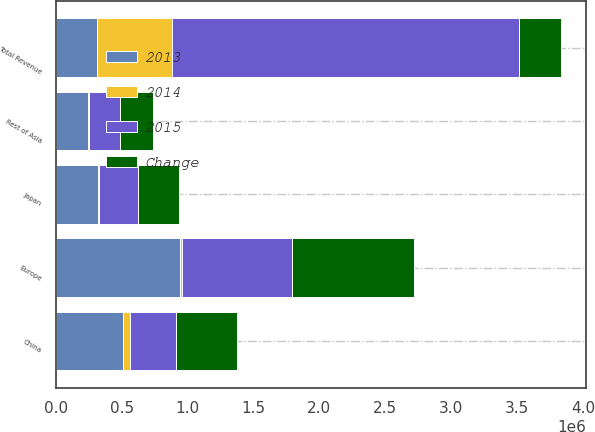Convert chart to OTSL. <chart><loc_0><loc_0><loc_500><loc_500><stacked_bar_chart><ecel><fcel>Europe<fcel>Japan<fcel>China<fcel>Rest of Asia<fcel>Total Revenue<nl><fcel>2013<fcel>939230<fcel>319569<fcel>511365<fcel>242460<fcel>313812<nl><fcel>Change<fcel>924477<fcel>308054<fcel>459260<fcel>254471<fcel>313812<nl><fcel>2015<fcel>840585<fcel>292804<fcel>349575<fcel>230241<fcel>2.63369e+06<nl><fcel>2014<fcel>14753<fcel>11515<fcel>52105<fcel>12011<fcel>570319<nl></chart> 